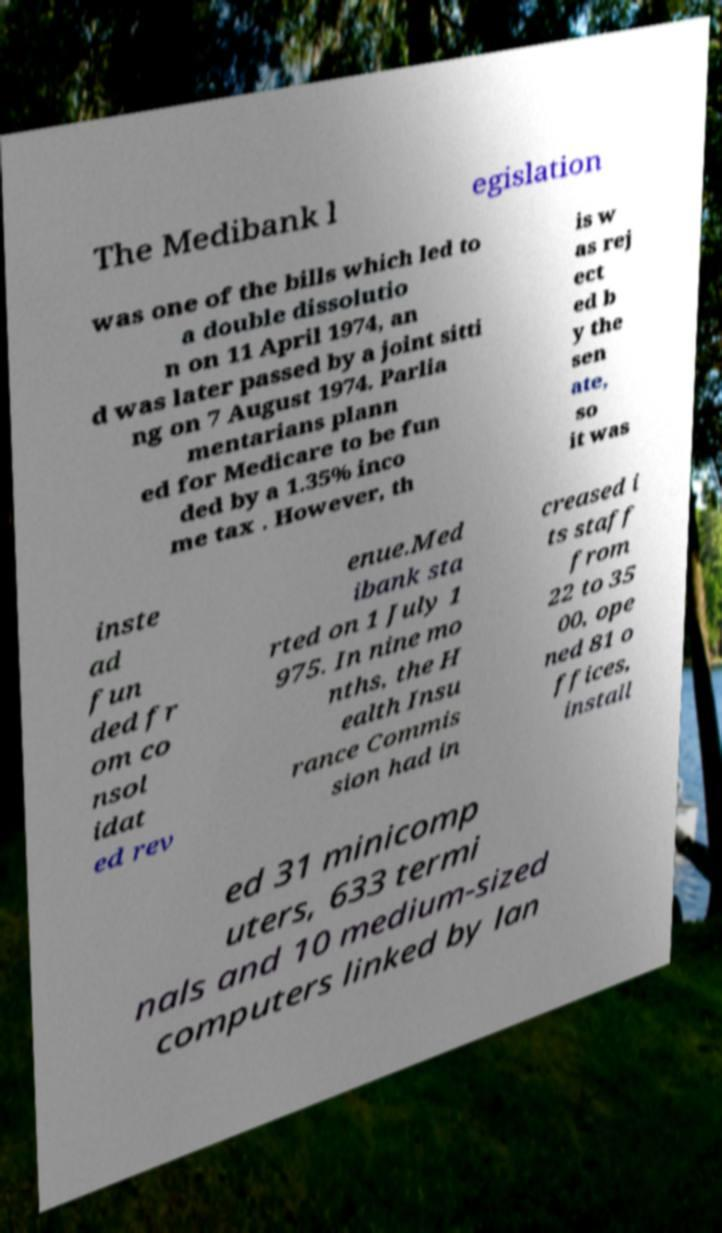I need the written content from this picture converted into text. Can you do that? The Medibank l egislation was one of the bills which led to a double dissolutio n on 11 April 1974, an d was later passed by a joint sitti ng on 7 August 1974. Parlia mentarians plann ed for Medicare to be fun ded by a 1.35% inco me tax . However, th is w as rej ect ed b y the sen ate, so it was inste ad fun ded fr om co nsol idat ed rev enue.Med ibank sta rted on 1 July 1 975. In nine mo nths, the H ealth Insu rance Commis sion had in creased i ts staff from 22 to 35 00, ope ned 81 o ffices, install ed 31 minicomp uters, 633 termi nals and 10 medium-sized computers linked by lan 